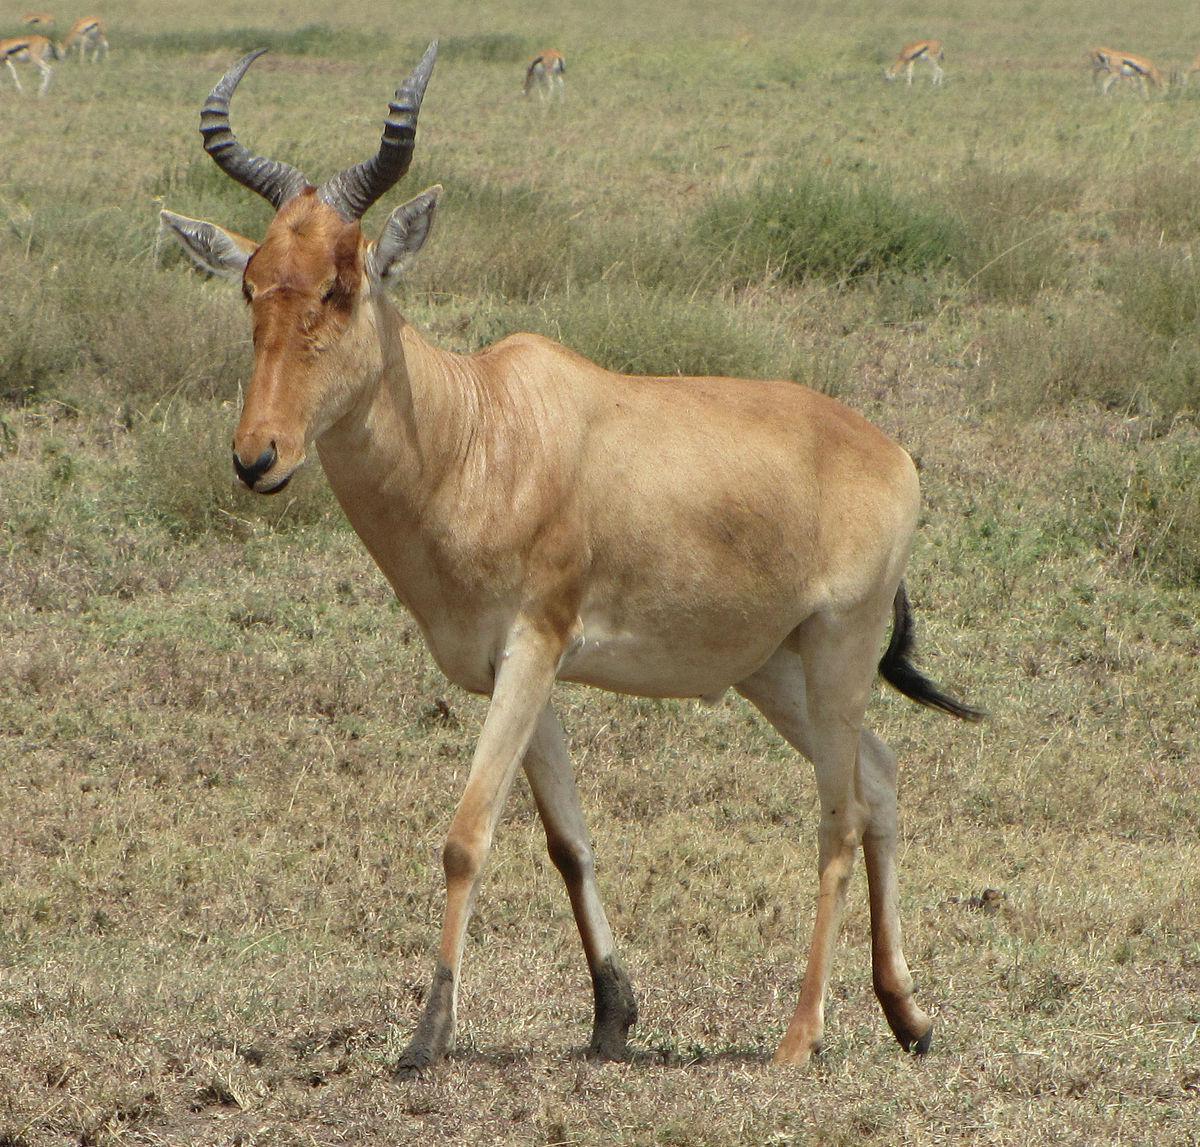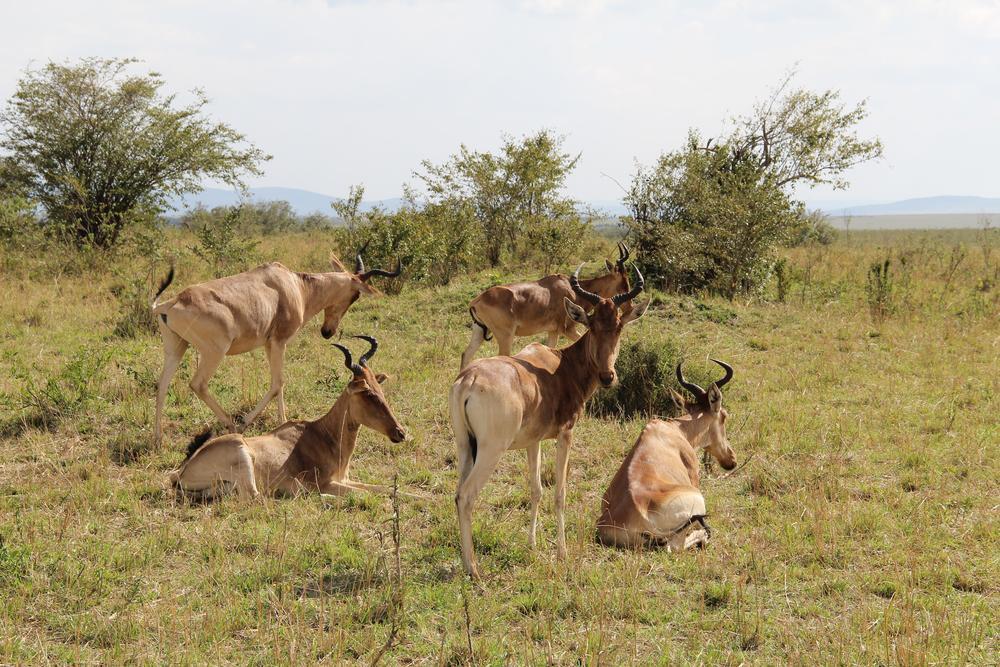The first image is the image on the left, the second image is the image on the right. For the images displayed, is the sentence "There are two antelope together in the right image." factually correct? Answer yes or no. No. 